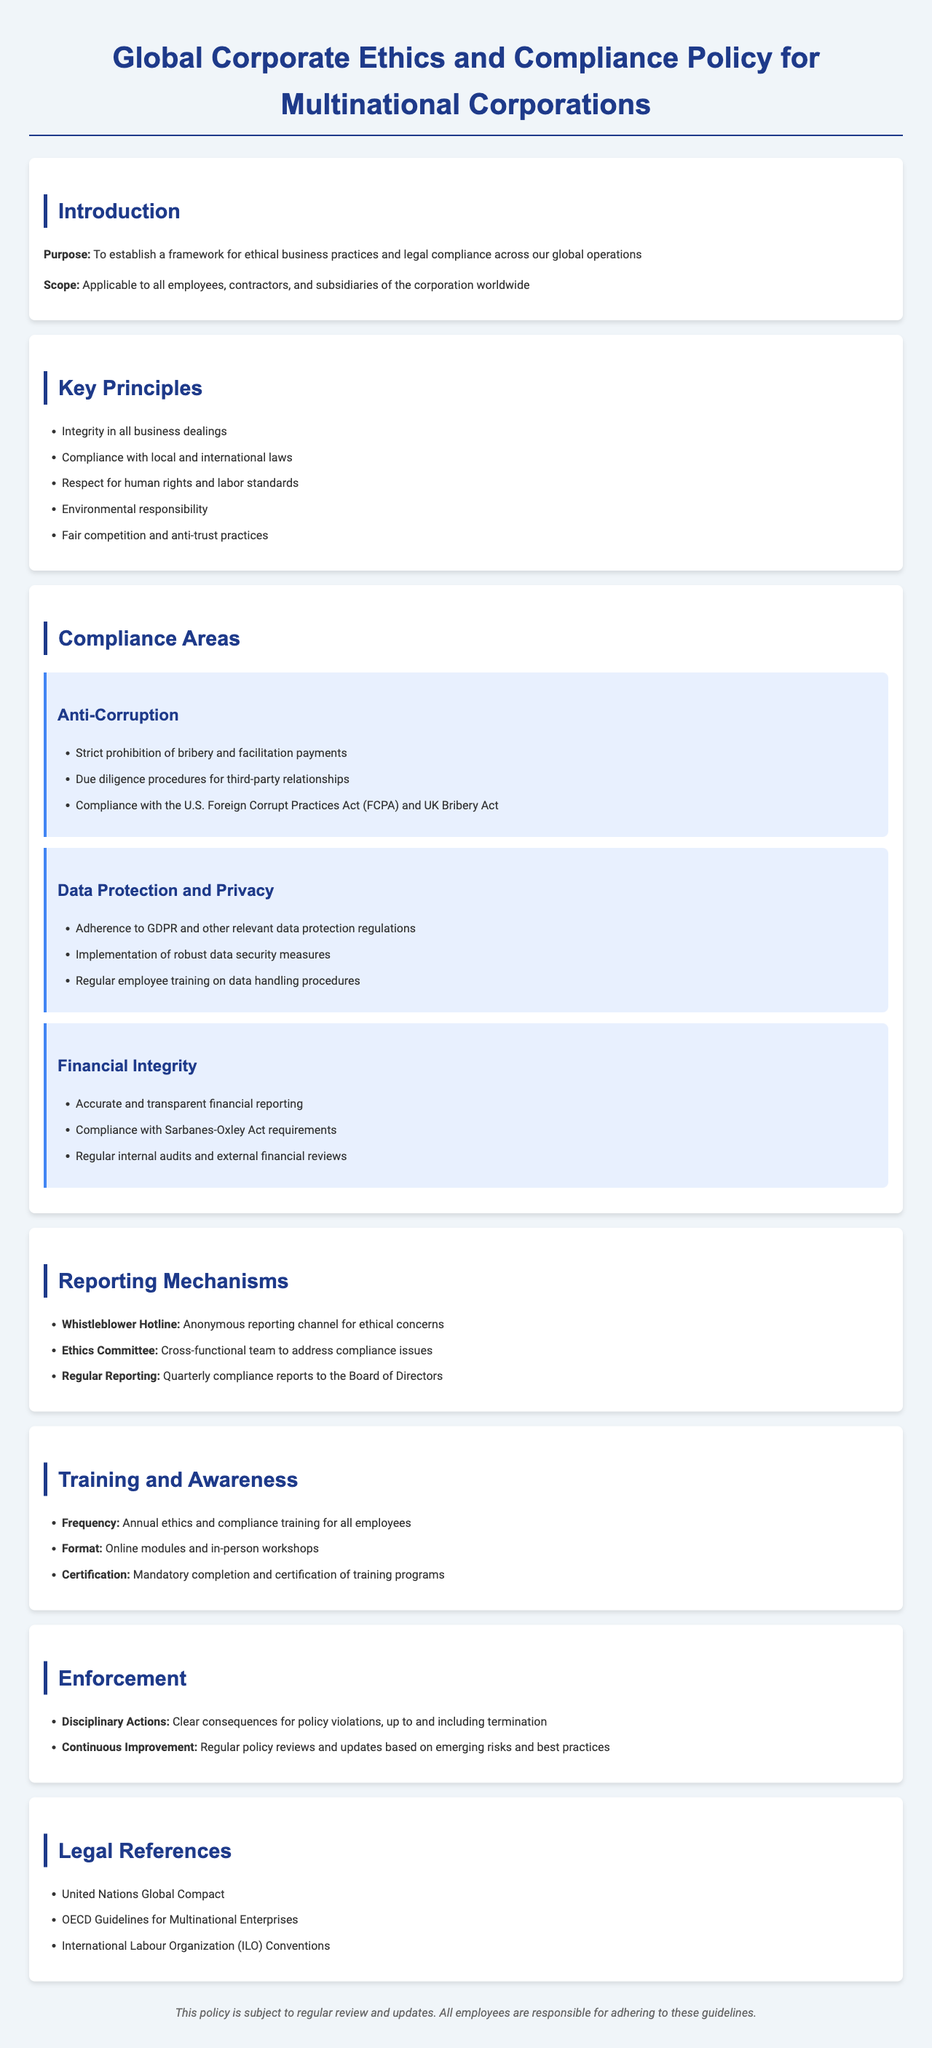What is the purpose of the policy? The purpose of the policy is to establish a framework for ethical business practices and legal compliance across global operations.
Answer: To establish a framework for ethical business practices and legal compliance across global operations Who does the policy apply to? The scope of the policy indicates it is applicable to all employees, contractors, and subsidiaries of the corporation worldwide.
Answer: All employees, contractors, and subsidiaries What is the frequency of ethics and compliance training? The policy specifies that training should occur annually for all employees.
Answer: Annual What legislation does the policy comply with regarding financial integrity? The document mentions that financial integrity must comply with the Sarbanes-Oxley Act requirements.
Answer: Sarbanes-Oxley Act What are the consequences for policy violations? The enforcement section outlines that clear consequences include disciplinary actions, up to and including termination.
Answer: Up to and including termination What is the focus of the section on anti-corruption? The anti-corruption section establishes a strict prohibition on bribery and facilitation payments.
Answer: Bribery and facilitation payments Which organization lays out guidelines for multinational enterprises? The legal references section includes the OECD Guidelines for Multinational Enterprises.
Answer: OECD Guidelines for Multinational Enterprises How often are compliance reports submitted to the Board of Directors? The reporting mechanisms state that quarterly compliance reports are provided to the Board.
Answer: Quarterly What is required in the data protection and privacy compliance area? The document emphasizes adherence to GDPR and other relevant data protection regulations.
Answer: GDPR and other relevant data protection regulations 